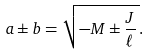Convert formula to latex. <formula><loc_0><loc_0><loc_500><loc_500>a \pm b = \sqrt { - M \pm \frac { J } { \ell } \, } .</formula> 